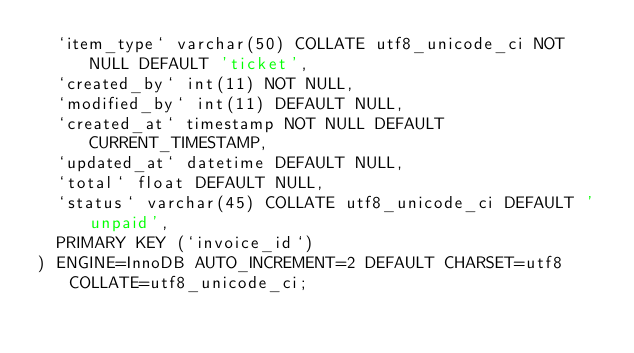Convert code to text. <code><loc_0><loc_0><loc_500><loc_500><_SQL_>  `item_type` varchar(50) COLLATE utf8_unicode_ci NOT NULL DEFAULT 'ticket',
  `created_by` int(11) NOT NULL,
  `modified_by` int(11) DEFAULT NULL,
  `created_at` timestamp NOT NULL DEFAULT CURRENT_TIMESTAMP,
  `updated_at` datetime DEFAULT NULL,
  `total` float DEFAULT NULL,
  `status` varchar(45) COLLATE utf8_unicode_ci DEFAULT 'unpaid',
  PRIMARY KEY (`invoice_id`)
) ENGINE=InnoDB AUTO_INCREMENT=2 DEFAULT CHARSET=utf8 COLLATE=utf8_unicode_ci;
</code> 